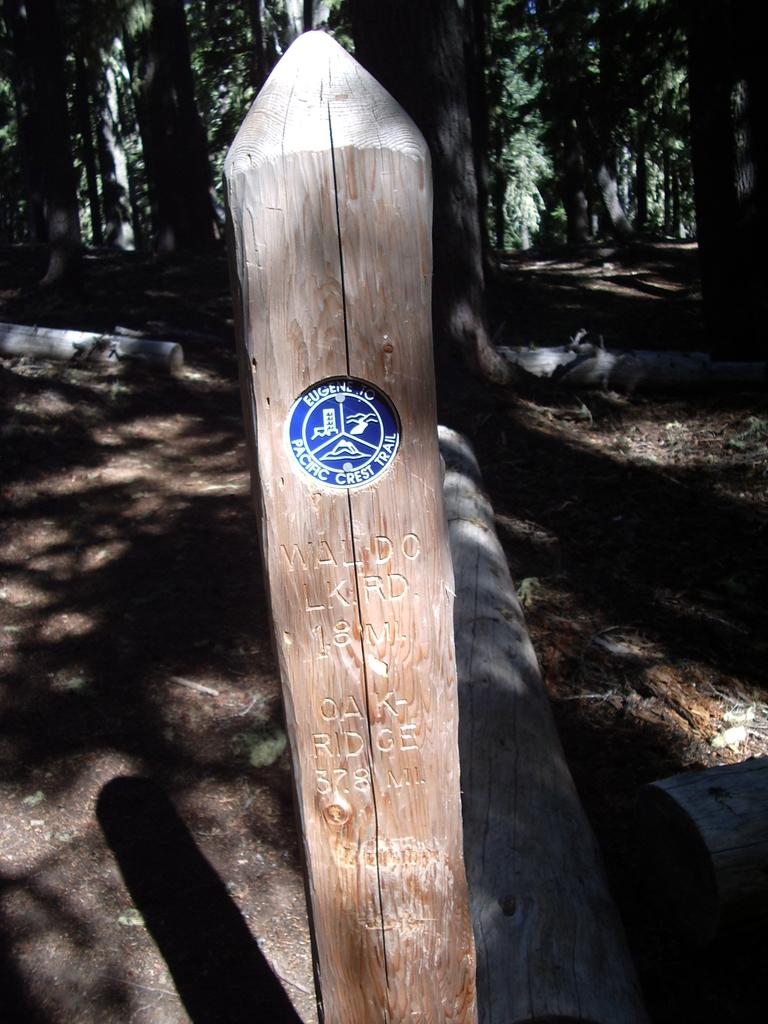What is located in the foreground of the image? There is a wooden pole in the foreground of the image. What can be seen on the wooden pole? Something is written on the wooden pole. What type of natural environment is visible in the background of the image? There are trees in the background of the image. What scent can be detected from the image? There is no information about a scent in the image, as it only features a wooden pole with writing and trees in the background. 